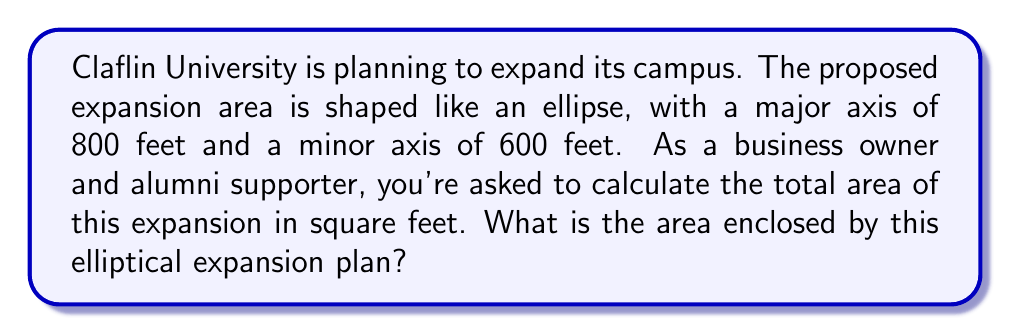Show me your answer to this math problem. Let's approach this step-by-step:

1) The formula for the area of an ellipse is:

   $$A = \pi ab$$

   where $a$ is half the length of the major axis and $b$ is half the length of the minor axis.

2) In this case:
   - Major axis = 800 feet, so $a = 400$ feet
   - Minor axis = 600 feet, so $b = 300$ feet

3) Plugging these values into our formula:

   $$A = \pi (400)(300)$$

4) Simplify:

   $$A = 120,000\pi$$

5) Using 3.14159 as an approximation for $\pi$:

   $$A \approx 120,000 * 3.14159 = 376,990.8$$

6) Rounding to the nearest square foot:

   $$A \approx 376,991 \text{ square feet}$$

This area represents the total space that will be added to the Claflin University campus through this elliptical expansion plan.
Answer: 376,991 square feet 